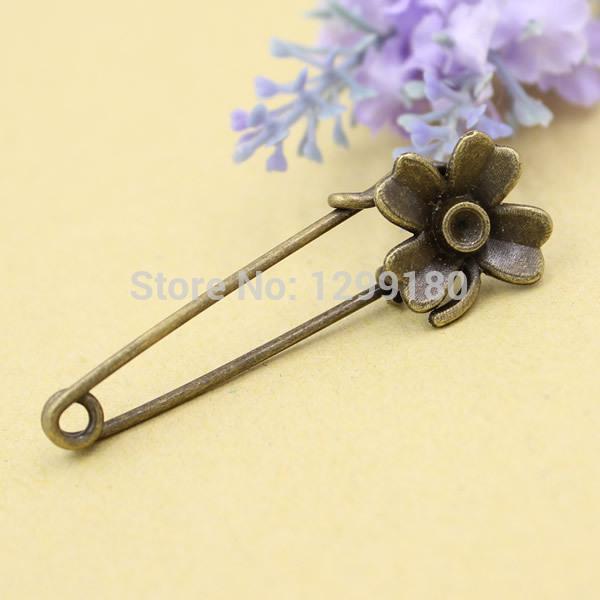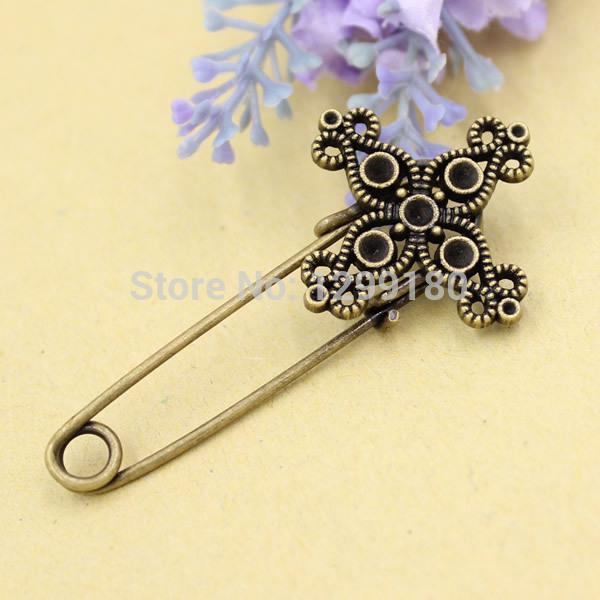The first image is the image on the left, the second image is the image on the right. Assess this claim about the two images: "Each photo contains a single safety pin with a decorative clasp.". Correct or not? Answer yes or no. Yes. 